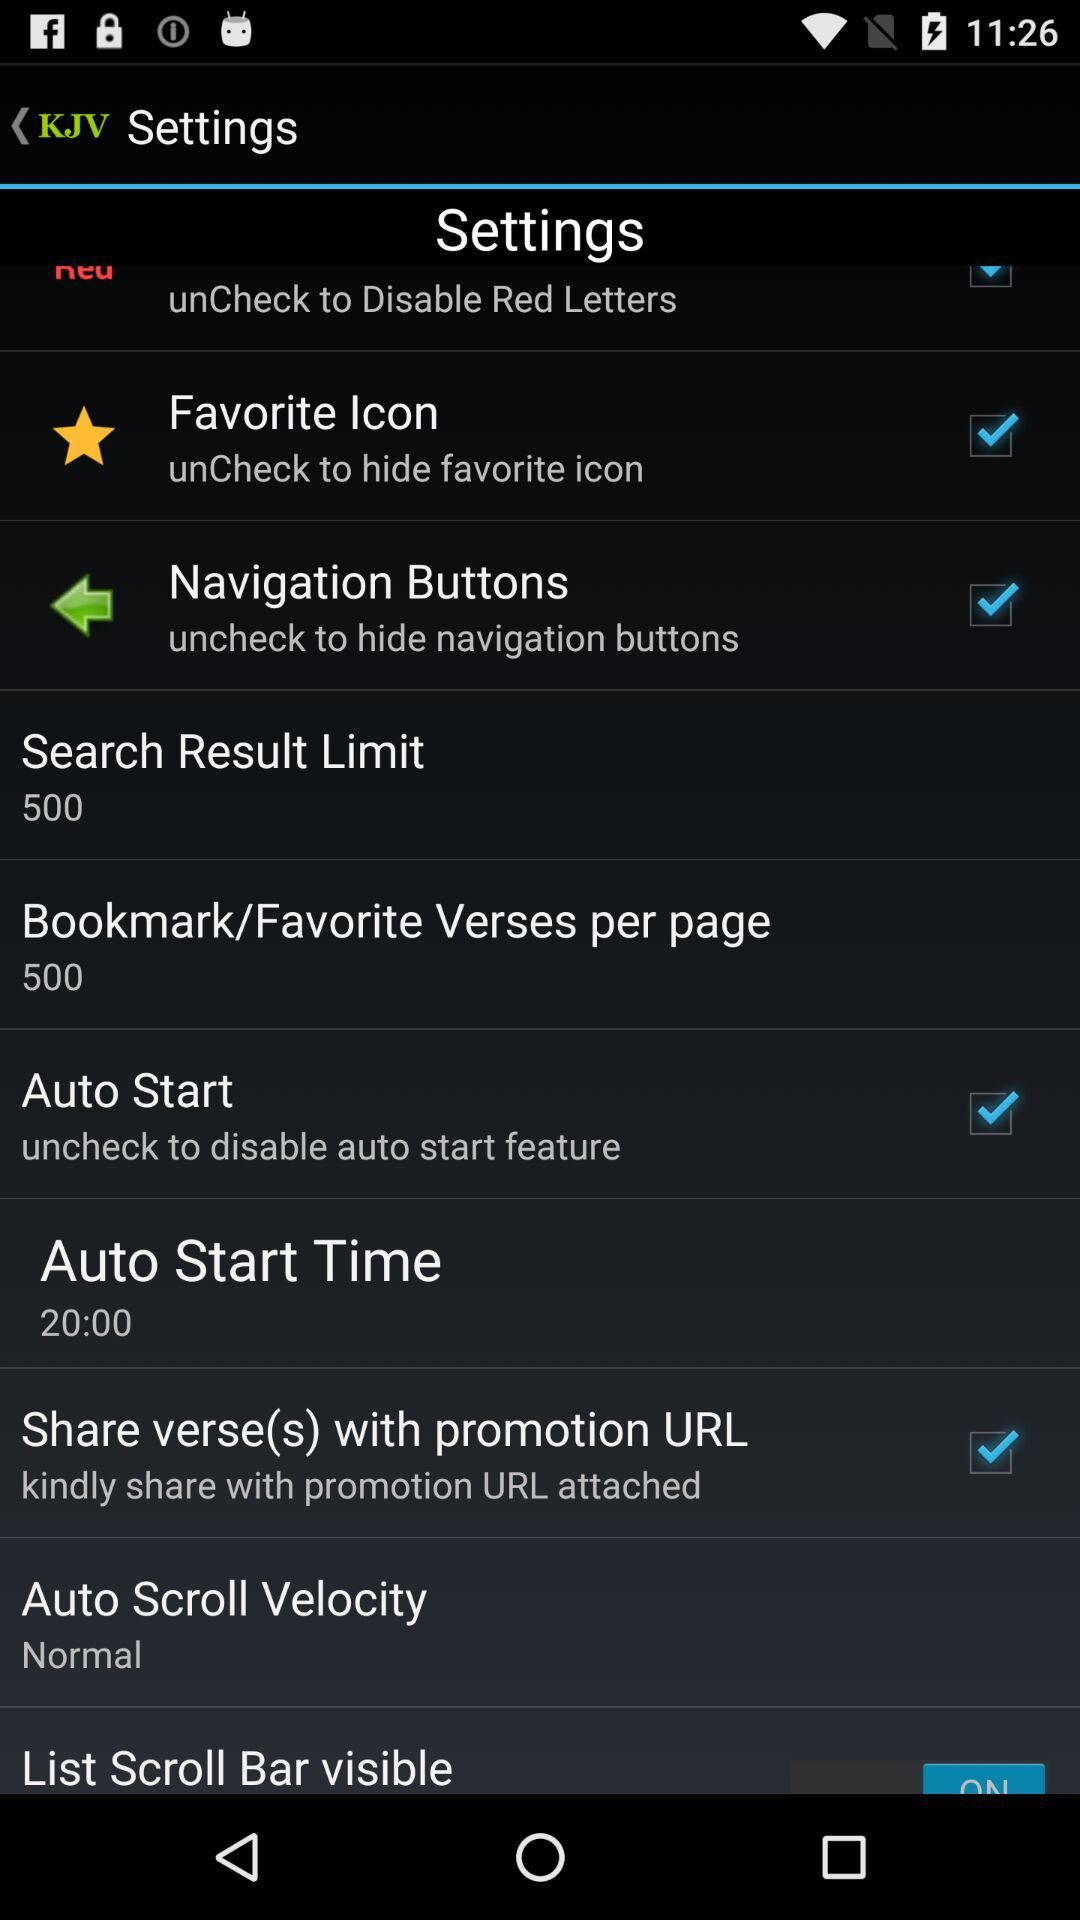What is the "Auto Scroll Velocity"? "Auto Scroll Velocity" is normal. 